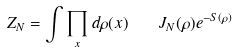Convert formula to latex. <formula><loc_0><loc_0><loc_500><loc_500>Z _ { N } = \int \prod _ { x } d \rho ( x ) \quad J _ { N } ( \rho ) e ^ { - S ( \rho ) }</formula> 